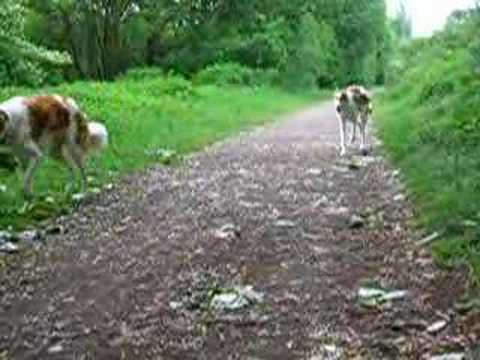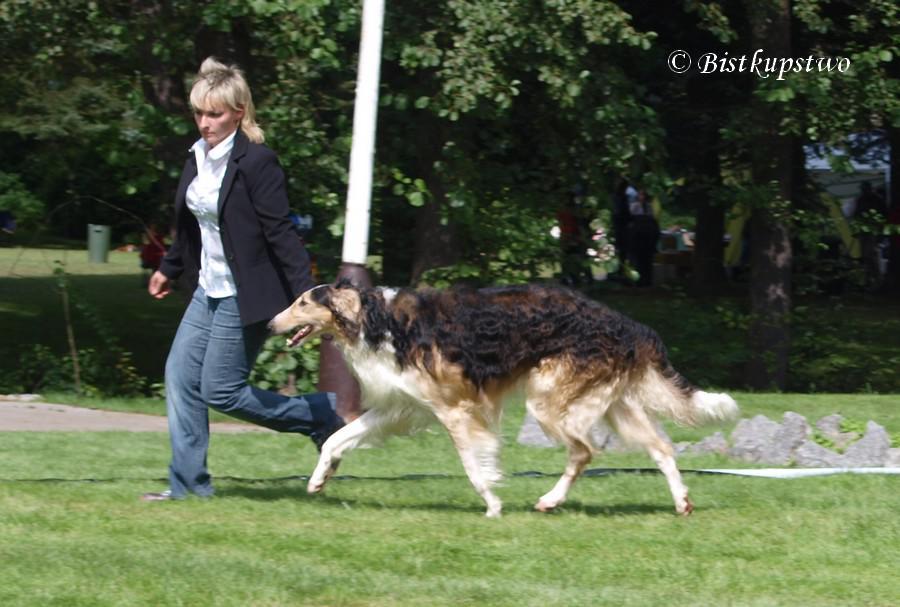The first image is the image on the left, the second image is the image on the right. Considering the images on both sides, is "At least one dog has its front paws off the ground." valid? Answer yes or no. No. The first image is the image on the left, the second image is the image on the right. Analyze the images presented: Is the assertion "Each image includes bounding hounds, and the right image shows a hound with its body leaning to the right as it runs forward." valid? Answer yes or no. No. 